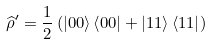<formula> <loc_0><loc_0><loc_500><loc_500>\widehat { \rho } ^ { \prime } = \frac { 1 } { 2 } \left ( \left | 0 0 \right \rangle \left \langle 0 0 \right | + \left | 1 1 \right \rangle \left \langle 1 1 \right | \right )</formula> 